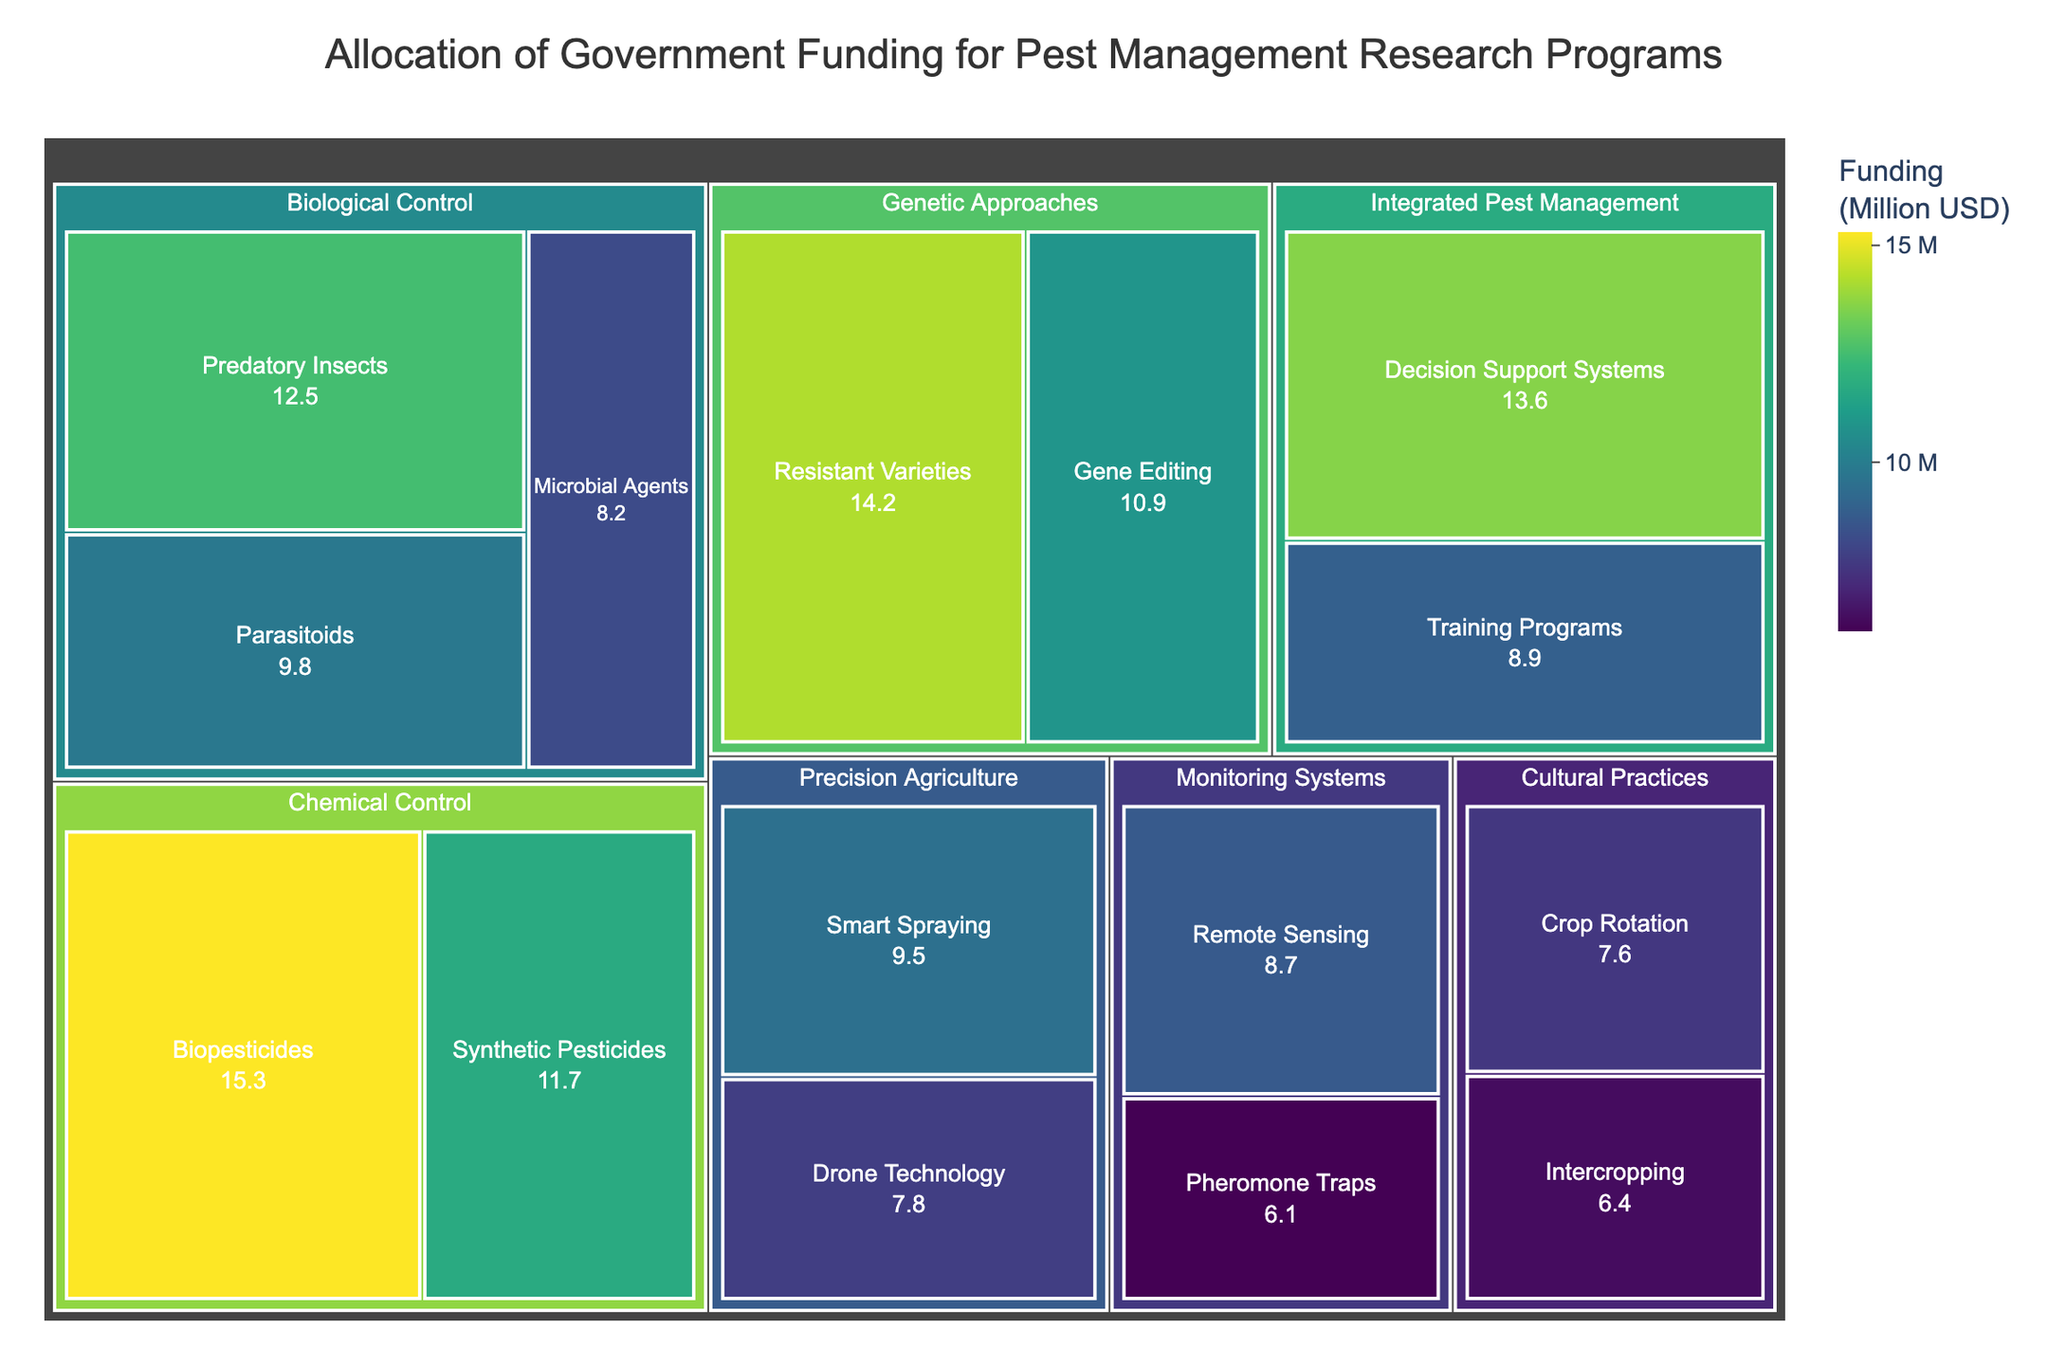What's the title of the treemap? The title of the treemap is usually located at the top of the figure. In this case, it is "Allocation of Government Funding for Pest Management Research Programs" since this is defined in the code that generates the plot.
Answer: Allocation of Government Funding for Pest Management Research Programs Which subcategory received the highest funding? By examining the sizes of the rectangles in the treemap, the largest rectangle corresponds to the subcategory with the highest funding. Here, it is "Biopesticides" in the category "Chemical Control" with $15.3 million in funding.
Answer: Biopesticides What is the total funding allocated to Biological Control methods? To find the total funding for Biological Control, sum the funding for all its subcategories: Predatory Insects ($12.5M), Parasitoids ($9.8M), and Microbial Agents ($8.2M). Thus, $12.5M + $9.8M + $8.2M = $30.5M.
Answer: $30.5M How does the funding for Smart Spraying compare to that for Drone Technology? Look at the sizes of the rectangles for "Smart Spraying" and "Drone Technology" under "Precision Agriculture." Smart Spraying has $9.5 million, and Drone Technology has $7.8 million. Smart Spraying received $1.7 million more than Drone Technology.
Answer: $1.7 million more What is the funding difference between Integrated Pest Management and Genetic Approaches? Sum the funding for subcategories under both categories. Integrated Pest Management: Decision Support Systems ($13.6M) + Training Programs ($8.9M) = $22.5M. Genetic Approaches: Resistant Varieties ($14.2M) + Gene Editing ($10.9M) = $25.1M. The difference is $25.1M - $22.5M = $2.6M.
Answer: $2.6 million Which category has the largest number of subcategories? Count the subcategories within each main category from the treemap. Biological Control, Genetic Approaches, and Precision Agriculture each have 3 subcategories. The winner in terms of quantity alone here could be seen after proper counting and checking.
Answer: Biological Control, Genetic Approaches, and Precision Agriculture What is the average funding per subcategory in Monitoring Systems? Sum the funding for subcategories in Monitoring Systems and divide by the number of subcategories. Remote Sensing ($8.7M) + Pheromone Traps ($6.1M) = $14.8M. There are 2 subcategories, so the average is $14.8M / 2 = $7.4M.
Answer: $7.4M Between Cultural Practices and Monitoring Systems, which category received more funding and by how much? Calculate the total funding for each category. Cultural Practices: Crop Rotation ($7.6M) + Intercropping ($6.4M) = $14.0M. Monitoring Systems: Remote Sensing ($8.7M) + Pheromone Traps ($6.1M) = $14.8M. Monitoring Systems received $14.8M - $14.0M = $0.8M more.
Answer: $0.8 million more How much funding is allocated to resistant varieties and gene editing combined? Add the funding amounts for both subcategories under Genetic Approaches. Resistant Varieties ($14.2M) + Gene Editing ($10.9M) = $25.1M.
Answer: $25.1 million 